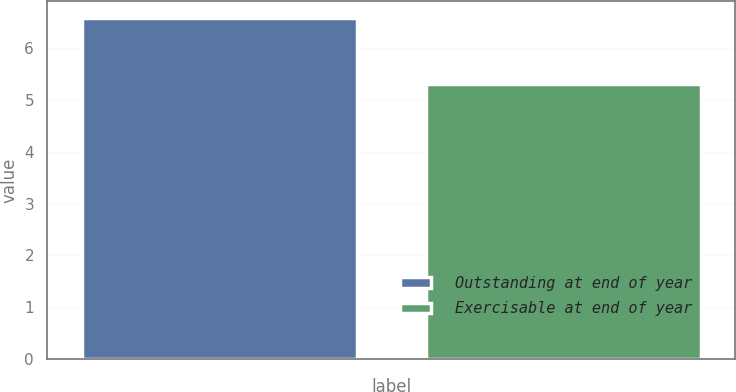<chart> <loc_0><loc_0><loc_500><loc_500><bar_chart><fcel>Outstanding at end of year<fcel>Exercisable at end of year<nl><fcel>6.57<fcel>5.3<nl></chart> 